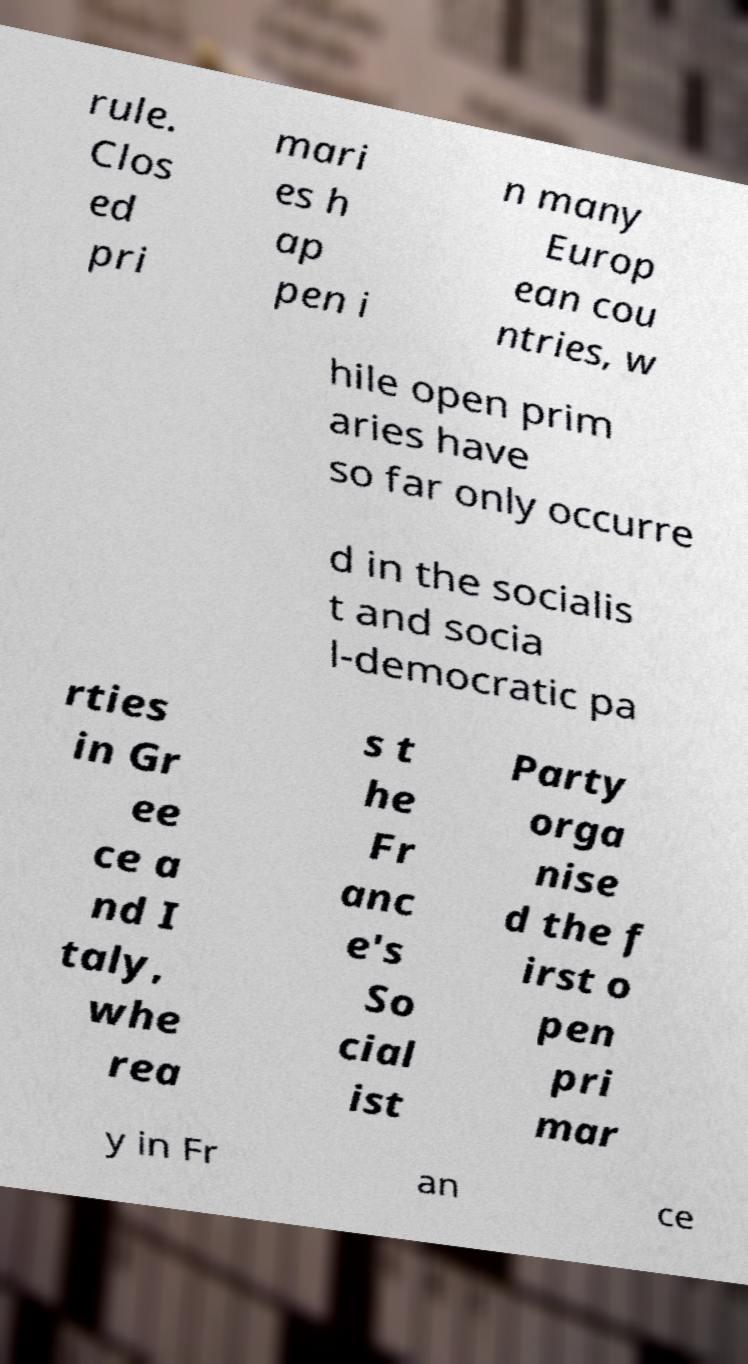Can you accurately transcribe the text from the provided image for me? rule. Clos ed pri mari es h ap pen i n many Europ ean cou ntries, w hile open prim aries have so far only occurre d in the socialis t and socia l-democratic pa rties in Gr ee ce a nd I taly, whe rea s t he Fr anc e's So cial ist Party orga nise d the f irst o pen pri mar y in Fr an ce 